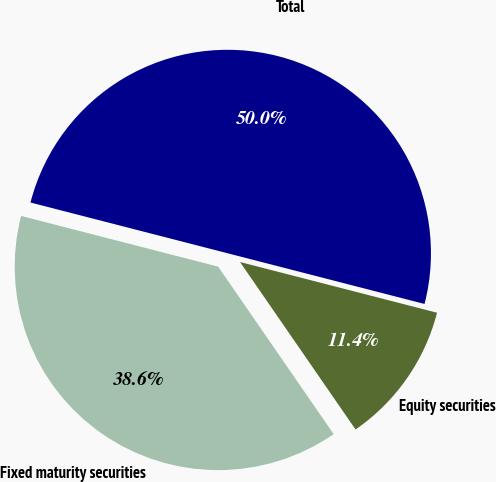<chart> <loc_0><loc_0><loc_500><loc_500><pie_chart><fcel>Fixed maturity securities<fcel>Equity securities<fcel>Total<nl><fcel>38.62%<fcel>11.38%<fcel>50.0%<nl></chart> 